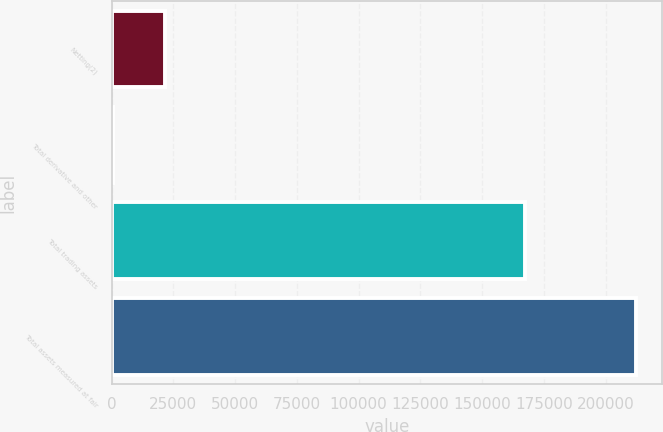Convert chart to OTSL. <chart><loc_0><loc_0><loc_500><loc_500><bar_chart><fcel>Netting(2)<fcel>Total derivative and other<fcel>Total trading assets<fcel>Total assets measured at fair<nl><fcel>21740.4<fcel>577<fcel>167302<fcel>212211<nl></chart> 